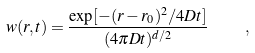Convert formula to latex. <formula><loc_0><loc_0><loc_500><loc_500>w ( { r } , t ) = \frac { \exp [ - ( { r } - { r } _ { 0 } ) ^ { 2 } / 4 D t ] } { ( 4 \pi D t ) ^ { d / 2 } } \quad ,</formula> 